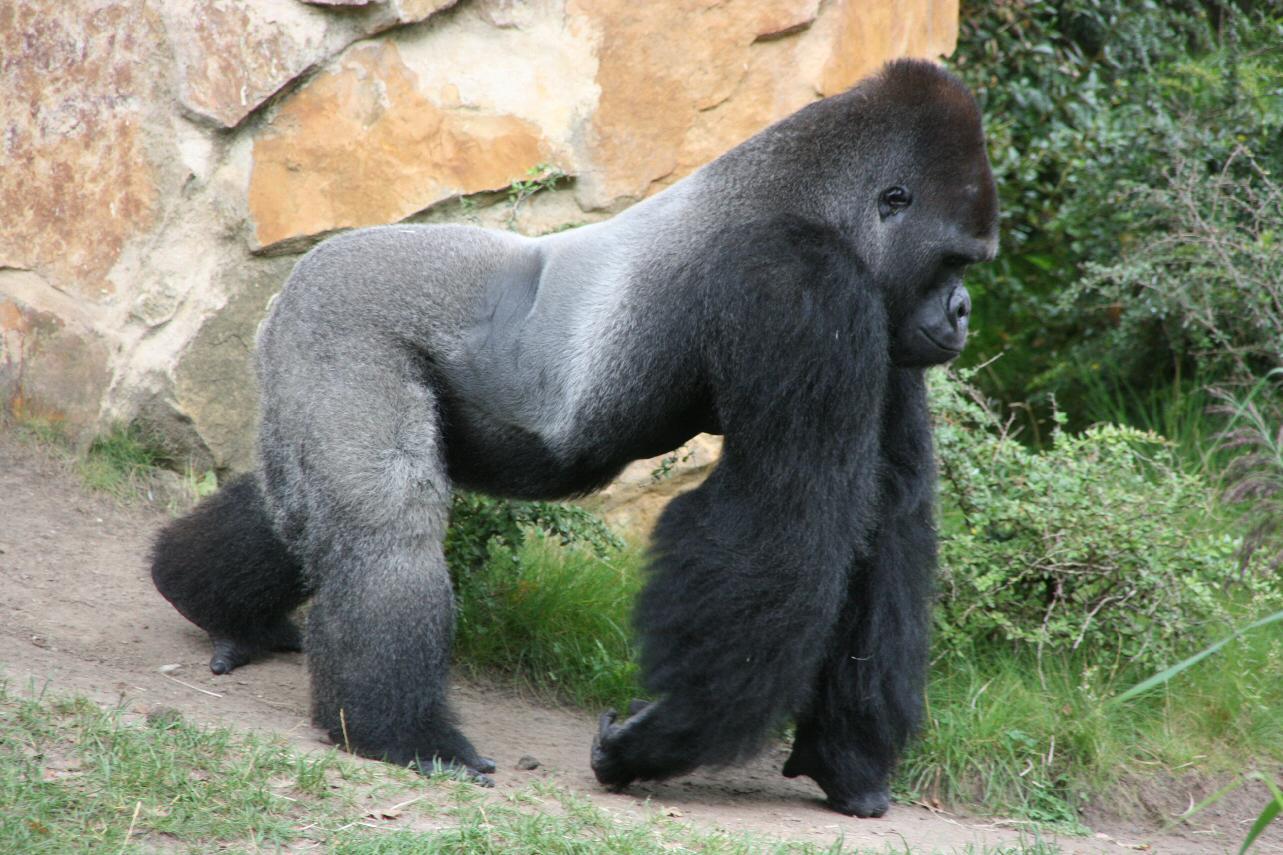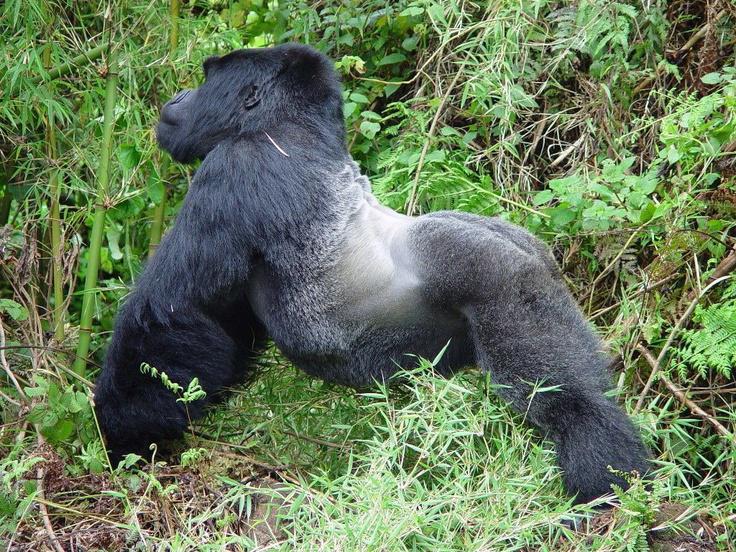The first image is the image on the left, the second image is the image on the right. For the images shown, is this caption "The baboon on the left is holding a baby baboon and sitting on the grass." true? Answer yes or no. No. The first image is the image on the left, the second image is the image on the right. Evaluate the accuracy of this statement regarding the images: "The left image contains a gorilla sitting down and looking towards the right.". Is it true? Answer yes or no. No. 